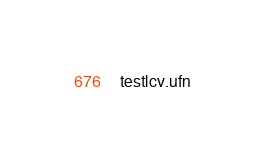Convert code to text. <code><loc_0><loc_0><loc_500><loc_500><_Cuda_>testlcv.ufn
</code> 